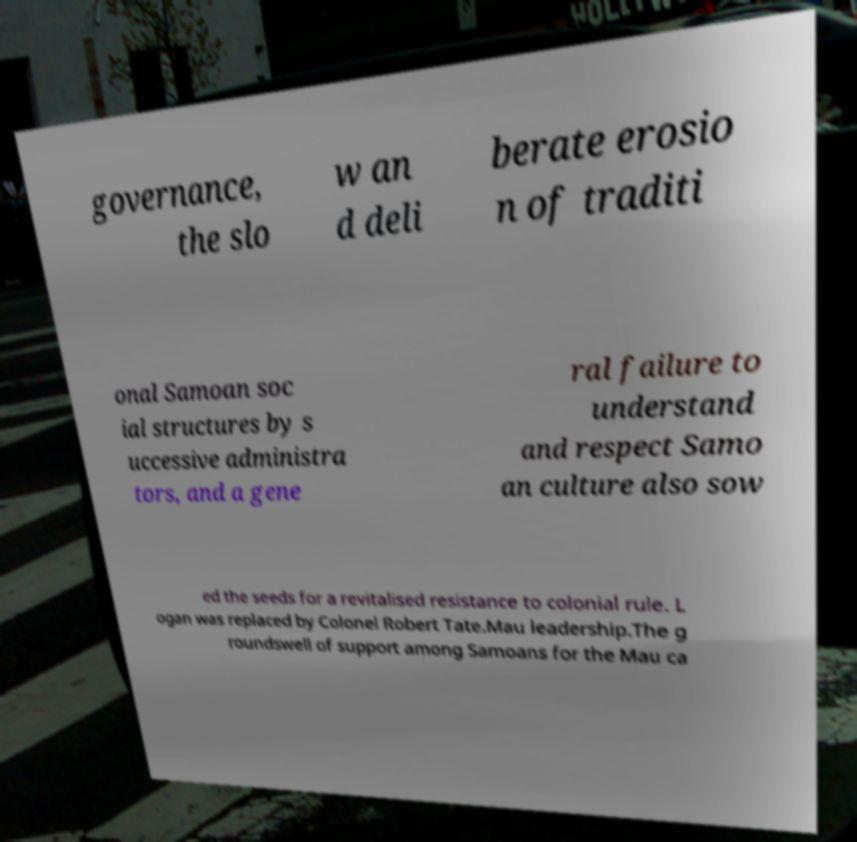Please identify and transcribe the text found in this image. governance, the slo w an d deli berate erosio n of traditi onal Samoan soc ial structures by s uccessive administra tors, and a gene ral failure to understand and respect Samo an culture also sow ed the seeds for a revitalised resistance to colonial rule. L ogan was replaced by Colonel Robert Tate.Mau leadership.The g roundswell of support among Samoans for the Mau ca 